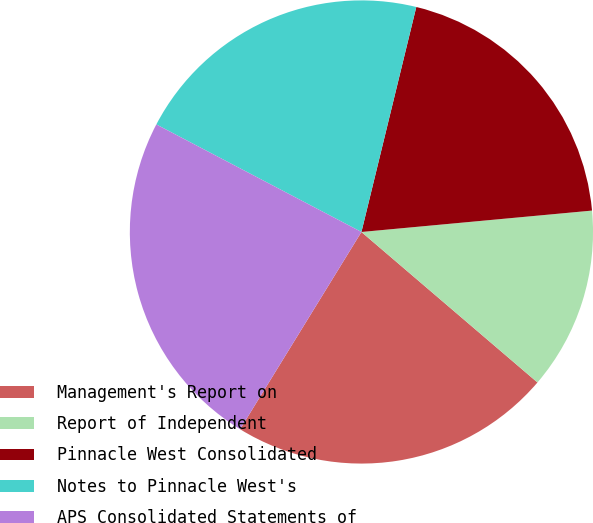Convert chart. <chart><loc_0><loc_0><loc_500><loc_500><pie_chart><fcel>Management's Report on<fcel>Report of Independent<fcel>Pinnacle West Consolidated<fcel>Notes to Pinnacle West's<fcel>APS Consolidated Statements of<nl><fcel>22.52%<fcel>12.73%<fcel>19.72%<fcel>21.12%<fcel>23.91%<nl></chart> 